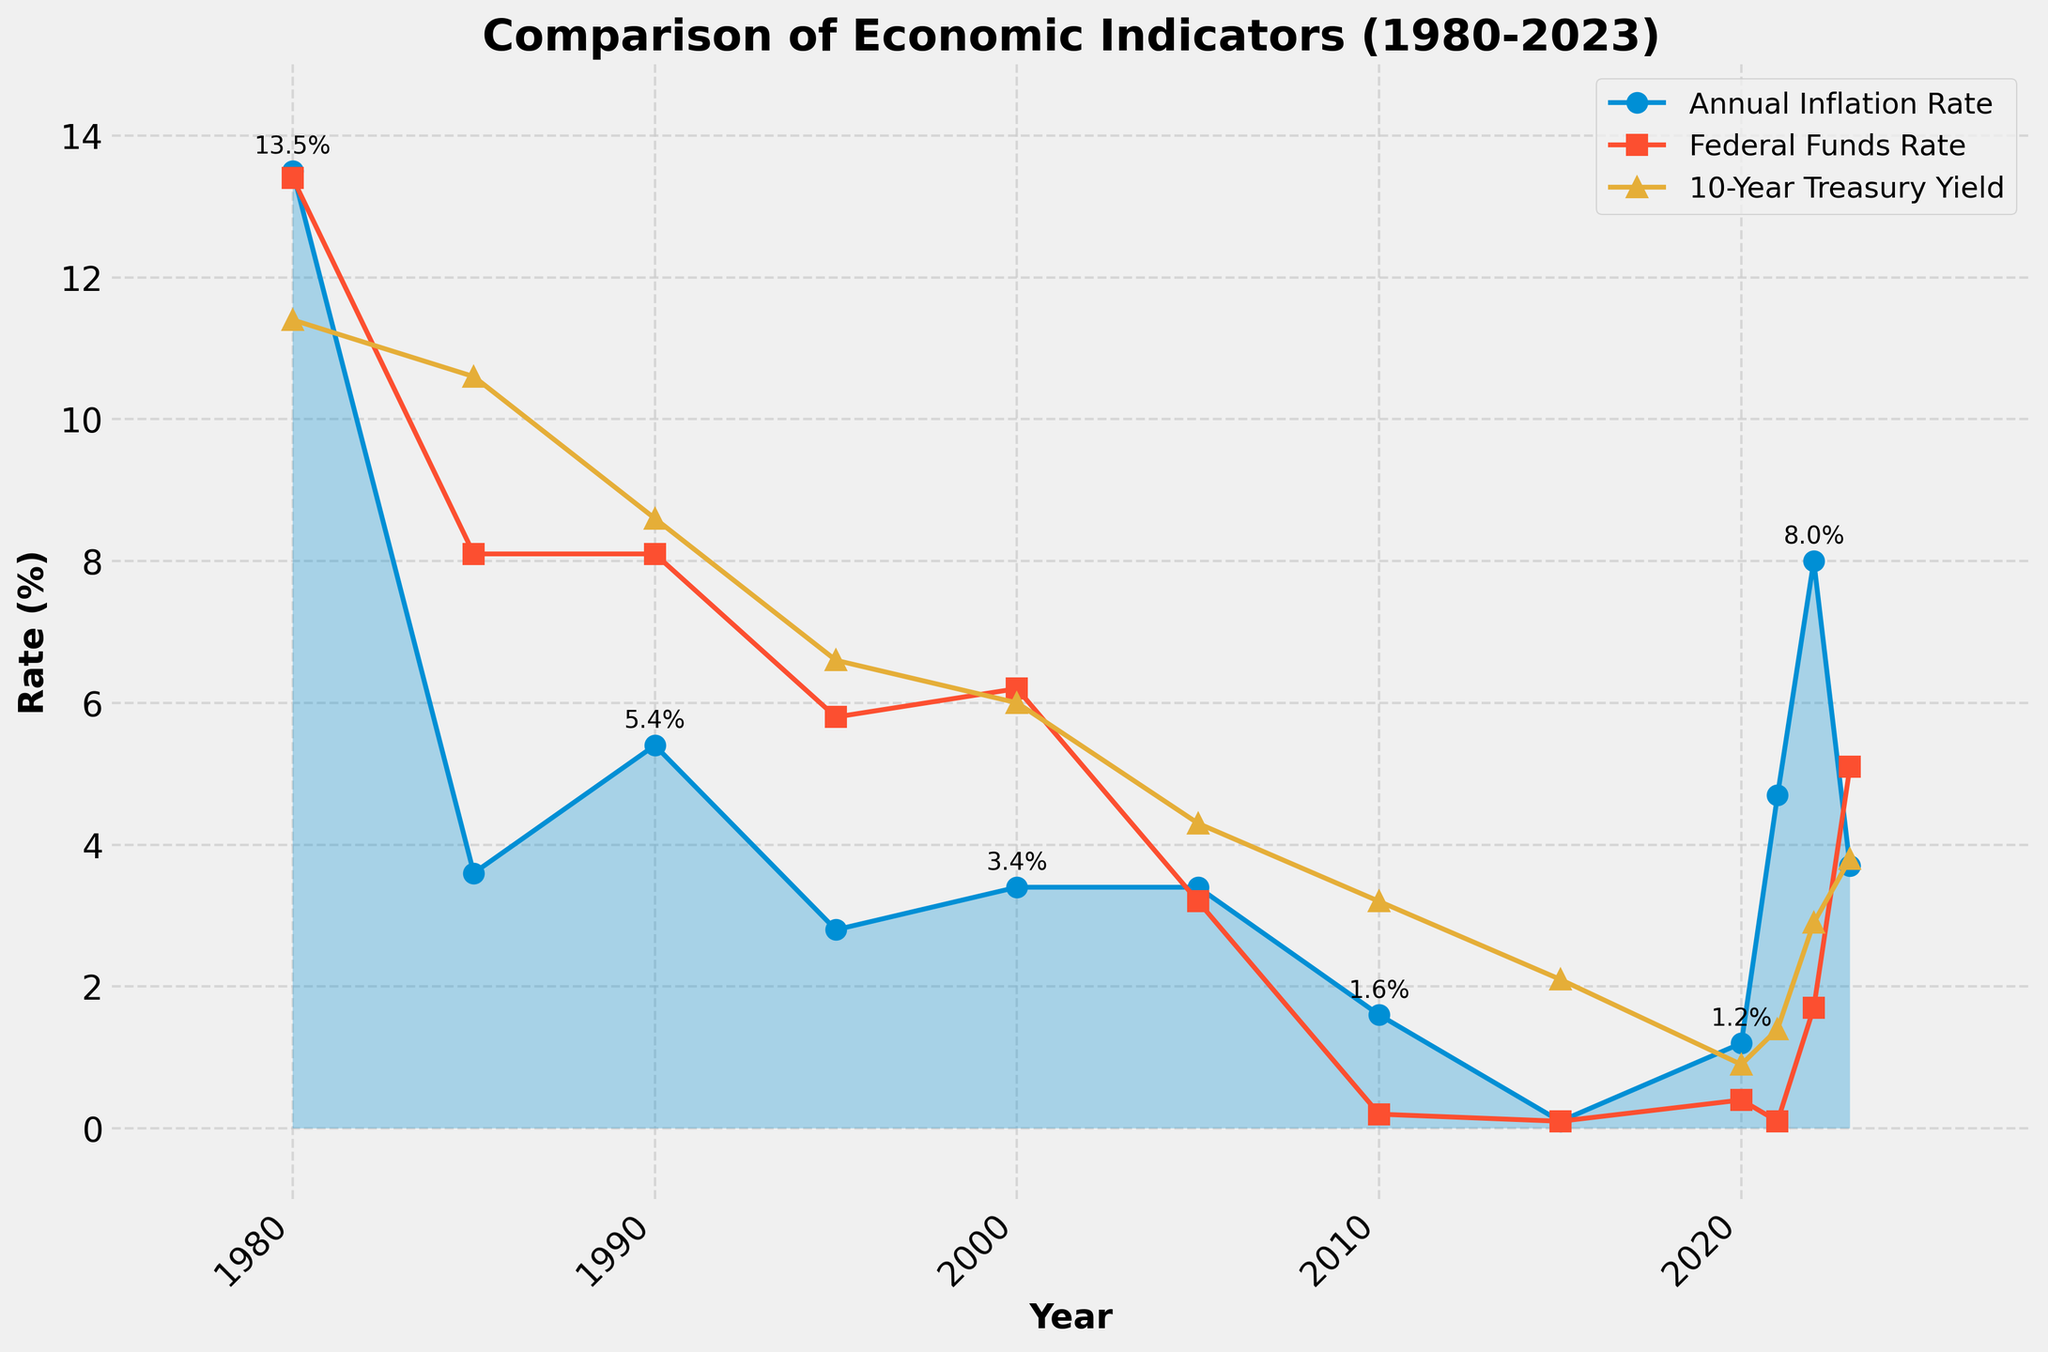What's the average Federal Funds Rate (%) for the years 1980, 2000, and 2023? First, identify the Federal Funds Rates for the years 1980 (13.4%), 2000 (6.2%), and 2023 (5.1%). Sum these rates: 13.4 + 6.2 + 5.1 = 24.7. Divide by the number of years (3): 24.7 / 3 = 8.23
Answer: 8.23% How does the Federal Funds Rate in 2023 compare to the Federal Funds Rate in 2022? Identify the rates: 2023 (5.1%) and 2022 (1.7%). Then, subtract the 2022 rate from the 2023 rate: 5.1 - 1.7 = 3.4. Therefore, the 2023 rate is higher by 3.4 percentage points.
Answer: Higher by 3.4 percentage points Which year had the highest Annual Inflation Rate? Observe the line representing the Annual Inflation Rate and find the peak point, which occurs in 1980 with a rate of 13.5%.
Answer: 1980 What is the difference between the Annual Inflation Rate and the 10-Year Treasury Yield in 2022? Identify the values for 2022: Annual Inflation Rate (8.0%) and 10-Year Treasury Yield (2.9%). Subtract the Treasury Yield from the Annual Inflation Rate: 8.0 - 2.9 = 5.1.
Answer: 5.1 percentage points Which rate remained relatively low from 2010 to 2021? Examine the trends of all three lines (Annual Inflation Rate, Federal Funds Rate, 10-Year Treasury Yield) from 2010 to 2021. The Federal Funds Rate remained low, ranging between 0.1% and 0.4%.
Answer: Federal Funds Rate When did the Annual Inflation Rate experience a sharp increase after a long period of stability, and by how much did it increase from the previous year? Identify the period of stability (2010-2020 with inflation rates between 0.1% and 1.6%) and the sharp increase afterward in 2021 (4.7%). The increase from 2020 (1.2%) to 2021 (4.7%) is calculated by 4.7 - 1.2 = 3.5.
Answer: 2021, increased by 3.5 percentage points In which year were all three rates (Annual Inflation Rate, Federal Funds Rate, 10-Year Treasury Yield) closest to each other, and what were the values? Inspect the figure where the three lines are closest. In 2020, the Annual Inflation Rate was 1.2%, the Federal Funds Rate was 0.4%, and the 10-Year Treasury Yield was 0.9%.
Answer: 2020, values were 1.2%, 0.4%, 0.9% Compare the highest value of the Federal Funds Rate and the 10-Year Treasury Yield over the period 1980-2023. Identify the highest values: Federal Funds Rate (13.4% in 1980) and 10-Year Treasury Yield (11.4% in 1980).
Answer: Federal Funds Rate: 13.4%, Treasury Yield: 11.4% How did the 10-Year Treasury Yield trend change from 1985 to 1990? Observe the trend line for the 10-Year Treasury Yield from 1985 (10.6%) to 1990 (8.6%). It shows a downward trend.
Answer: Decreased 